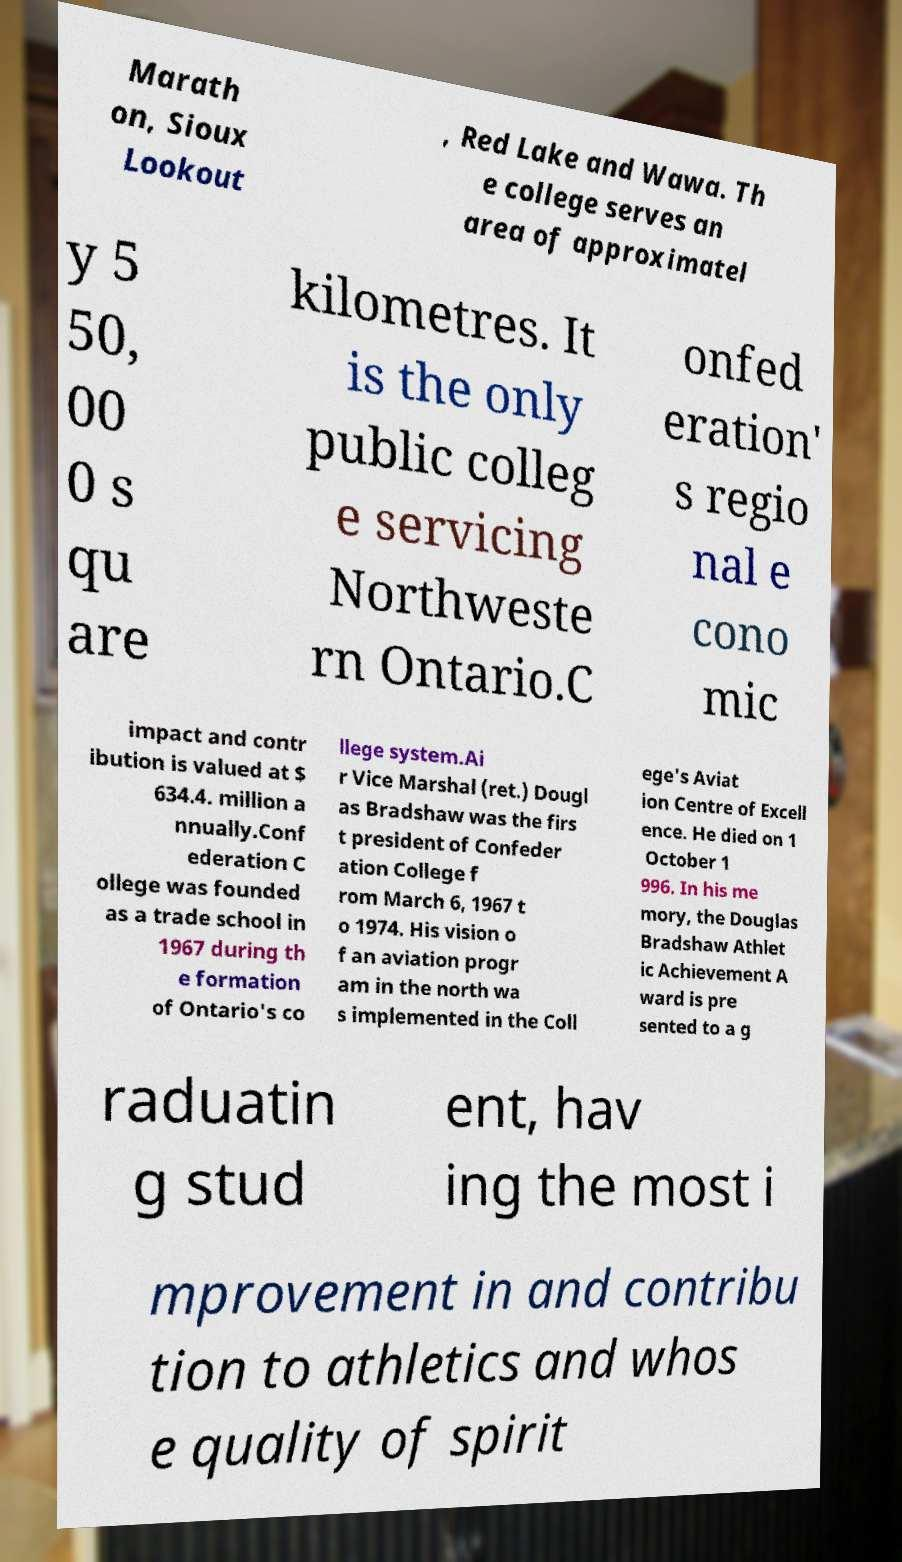Can you accurately transcribe the text from the provided image for me? Marath on, Sioux Lookout , Red Lake and Wawa. Th e college serves an area of approximatel y 5 50, 00 0 s qu are kilometres. It is the only public colleg e servicing Northweste rn Ontario.C onfed eration' s regio nal e cono mic impact and contr ibution is valued at $ 634.4. million a nnually.Conf ederation C ollege was founded as a trade school in 1967 during th e formation of Ontario's co llege system.Ai r Vice Marshal (ret.) Dougl as Bradshaw was the firs t president of Confeder ation College f rom March 6, 1967 t o 1974. His vision o f an aviation progr am in the north wa s implemented in the Coll ege's Aviat ion Centre of Excell ence. He died on 1 October 1 996. In his me mory, the Douglas Bradshaw Athlet ic Achievement A ward is pre sented to a g raduatin g stud ent, hav ing the most i mprovement in and contribu tion to athletics and whos e quality of spirit 